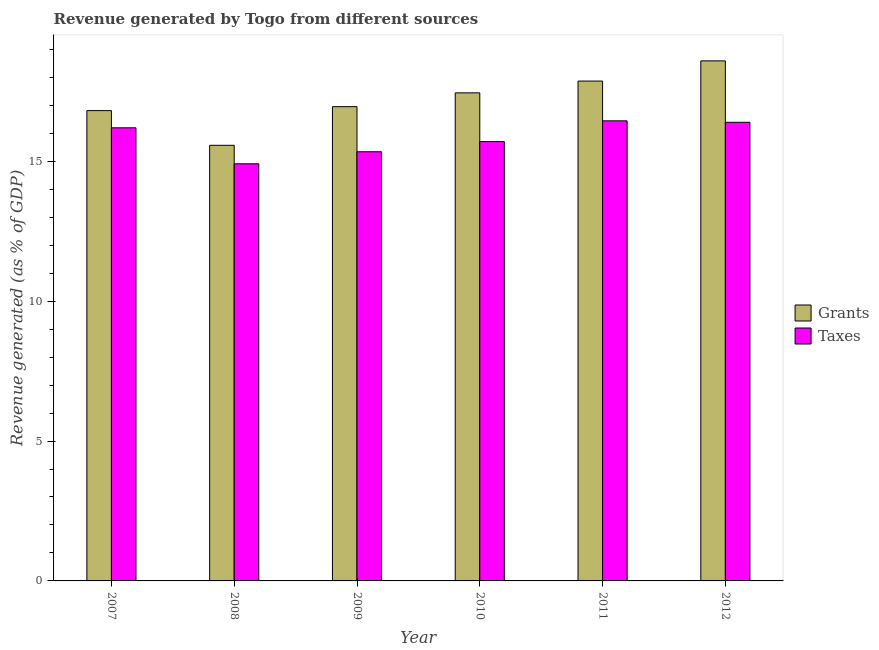How many different coloured bars are there?
Make the answer very short. 2. Are the number of bars per tick equal to the number of legend labels?
Your response must be concise. Yes. Are the number of bars on each tick of the X-axis equal?
Give a very brief answer. Yes. In how many cases, is the number of bars for a given year not equal to the number of legend labels?
Offer a very short reply. 0. What is the revenue generated by taxes in 2011?
Ensure brevity in your answer.  16.44. Across all years, what is the maximum revenue generated by taxes?
Offer a very short reply. 16.44. Across all years, what is the minimum revenue generated by grants?
Offer a very short reply. 15.57. In which year was the revenue generated by taxes maximum?
Your response must be concise. 2011. What is the total revenue generated by grants in the graph?
Make the answer very short. 103.22. What is the difference between the revenue generated by grants in 2007 and that in 2012?
Your response must be concise. -1.78. What is the difference between the revenue generated by grants in 2012 and the revenue generated by taxes in 2009?
Provide a succinct answer. 1.64. What is the average revenue generated by taxes per year?
Give a very brief answer. 15.83. In the year 2007, what is the difference between the revenue generated by grants and revenue generated by taxes?
Your answer should be compact. 0. In how many years, is the revenue generated by grants greater than 18 %?
Provide a succinct answer. 1. What is the ratio of the revenue generated by grants in 2007 to that in 2011?
Give a very brief answer. 0.94. What is the difference between the highest and the second highest revenue generated by grants?
Make the answer very short. 0.72. What is the difference between the highest and the lowest revenue generated by grants?
Your response must be concise. 3.02. In how many years, is the revenue generated by taxes greater than the average revenue generated by taxes taken over all years?
Your answer should be very brief. 3. What does the 1st bar from the left in 2011 represents?
Offer a terse response. Grants. What does the 2nd bar from the right in 2007 represents?
Your response must be concise. Grants. How many bars are there?
Your response must be concise. 12. Are all the bars in the graph horizontal?
Offer a very short reply. No. How many years are there in the graph?
Ensure brevity in your answer.  6. What is the difference between two consecutive major ticks on the Y-axis?
Your answer should be very brief. 5. Does the graph contain any zero values?
Ensure brevity in your answer.  No. Where does the legend appear in the graph?
Keep it short and to the point. Center right. What is the title of the graph?
Make the answer very short. Revenue generated by Togo from different sources. What is the label or title of the Y-axis?
Give a very brief answer. Revenue generated (as % of GDP). What is the Revenue generated (as % of GDP) in Grants in 2007?
Give a very brief answer. 16.81. What is the Revenue generated (as % of GDP) in Taxes in 2007?
Give a very brief answer. 16.2. What is the Revenue generated (as % of GDP) of Grants in 2008?
Ensure brevity in your answer.  15.57. What is the Revenue generated (as % of GDP) of Taxes in 2008?
Provide a succinct answer. 14.91. What is the Revenue generated (as % of GDP) in Grants in 2009?
Offer a terse response. 16.95. What is the Revenue generated (as % of GDP) of Taxes in 2009?
Give a very brief answer. 15.34. What is the Revenue generated (as % of GDP) of Grants in 2010?
Offer a terse response. 17.44. What is the Revenue generated (as % of GDP) in Taxes in 2010?
Provide a succinct answer. 15.7. What is the Revenue generated (as % of GDP) of Grants in 2011?
Provide a succinct answer. 17.87. What is the Revenue generated (as % of GDP) in Taxes in 2011?
Your response must be concise. 16.44. What is the Revenue generated (as % of GDP) in Grants in 2012?
Your answer should be compact. 18.59. What is the Revenue generated (as % of GDP) of Taxes in 2012?
Provide a succinct answer. 16.39. Across all years, what is the maximum Revenue generated (as % of GDP) of Grants?
Your response must be concise. 18.59. Across all years, what is the maximum Revenue generated (as % of GDP) in Taxes?
Your answer should be very brief. 16.44. Across all years, what is the minimum Revenue generated (as % of GDP) in Grants?
Your answer should be compact. 15.57. Across all years, what is the minimum Revenue generated (as % of GDP) of Taxes?
Make the answer very short. 14.91. What is the total Revenue generated (as % of GDP) in Grants in the graph?
Ensure brevity in your answer.  103.22. What is the total Revenue generated (as % of GDP) of Taxes in the graph?
Provide a short and direct response. 94.98. What is the difference between the Revenue generated (as % of GDP) in Grants in 2007 and that in 2008?
Keep it short and to the point. 1.24. What is the difference between the Revenue generated (as % of GDP) in Taxes in 2007 and that in 2008?
Keep it short and to the point. 1.29. What is the difference between the Revenue generated (as % of GDP) in Grants in 2007 and that in 2009?
Offer a terse response. -0.14. What is the difference between the Revenue generated (as % of GDP) of Taxes in 2007 and that in 2009?
Ensure brevity in your answer.  0.86. What is the difference between the Revenue generated (as % of GDP) of Grants in 2007 and that in 2010?
Provide a succinct answer. -0.64. What is the difference between the Revenue generated (as % of GDP) of Taxes in 2007 and that in 2010?
Offer a very short reply. 0.49. What is the difference between the Revenue generated (as % of GDP) of Grants in 2007 and that in 2011?
Make the answer very short. -1.06. What is the difference between the Revenue generated (as % of GDP) of Taxes in 2007 and that in 2011?
Keep it short and to the point. -0.25. What is the difference between the Revenue generated (as % of GDP) of Grants in 2007 and that in 2012?
Offer a very short reply. -1.78. What is the difference between the Revenue generated (as % of GDP) of Taxes in 2007 and that in 2012?
Provide a succinct answer. -0.2. What is the difference between the Revenue generated (as % of GDP) of Grants in 2008 and that in 2009?
Keep it short and to the point. -1.38. What is the difference between the Revenue generated (as % of GDP) in Taxes in 2008 and that in 2009?
Your response must be concise. -0.43. What is the difference between the Revenue generated (as % of GDP) of Grants in 2008 and that in 2010?
Your answer should be very brief. -1.87. What is the difference between the Revenue generated (as % of GDP) in Taxes in 2008 and that in 2010?
Your answer should be very brief. -0.79. What is the difference between the Revenue generated (as % of GDP) of Grants in 2008 and that in 2011?
Give a very brief answer. -2.3. What is the difference between the Revenue generated (as % of GDP) of Taxes in 2008 and that in 2011?
Offer a terse response. -1.53. What is the difference between the Revenue generated (as % of GDP) of Grants in 2008 and that in 2012?
Your answer should be very brief. -3.02. What is the difference between the Revenue generated (as % of GDP) in Taxes in 2008 and that in 2012?
Keep it short and to the point. -1.48. What is the difference between the Revenue generated (as % of GDP) of Grants in 2009 and that in 2010?
Make the answer very short. -0.49. What is the difference between the Revenue generated (as % of GDP) of Taxes in 2009 and that in 2010?
Your answer should be compact. -0.36. What is the difference between the Revenue generated (as % of GDP) in Grants in 2009 and that in 2011?
Your answer should be very brief. -0.91. What is the difference between the Revenue generated (as % of GDP) of Taxes in 2009 and that in 2011?
Make the answer very short. -1.1. What is the difference between the Revenue generated (as % of GDP) in Grants in 2009 and that in 2012?
Provide a short and direct response. -1.64. What is the difference between the Revenue generated (as % of GDP) in Taxes in 2009 and that in 2012?
Offer a terse response. -1.05. What is the difference between the Revenue generated (as % of GDP) in Grants in 2010 and that in 2011?
Ensure brevity in your answer.  -0.42. What is the difference between the Revenue generated (as % of GDP) in Taxes in 2010 and that in 2011?
Keep it short and to the point. -0.74. What is the difference between the Revenue generated (as % of GDP) of Grants in 2010 and that in 2012?
Ensure brevity in your answer.  -1.14. What is the difference between the Revenue generated (as % of GDP) in Taxes in 2010 and that in 2012?
Offer a very short reply. -0.69. What is the difference between the Revenue generated (as % of GDP) in Grants in 2011 and that in 2012?
Offer a terse response. -0.72. What is the difference between the Revenue generated (as % of GDP) of Taxes in 2011 and that in 2012?
Make the answer very short. 0.05. What is the difference between the Revenue generated (as % of GDP) in Grants in 2007 and the Revenue generated (as % of GDP) in Taxes in 2009?
Your answer should be very brief. 1.47. What is the difference between the Revenue generated (as % of GDP) in Grants in 2007 and the Revenue generated (as % of GDP) in Taxes in 2010?
Provide a short and direct response. 1.11. What is the difference between the Revenue generated (as % of GDP) of Grants in 2007 and the Revenue generated (as % of GDP) of Taxes in 2011?
Your answer should be very brief. 0.37. What is the difference between the Revenue generated (as % of GDP) in Grants in 2007 and the Revenue generated (as % of GDP) in Taxes in 2012?
Provide a short and direct response. 0.42. What is the difference between the Revenue generated (as % of GDP) in Grants in 2008 and the Revenue generated (as % of GDP) in Taxes in 2009?
Make the answer very short. 0.23. What is the difference between the Revenue generated (as % of GDP) of Grants in 2008 and the Revenue generated (as % of GDP) of Taxes in 2010?
Your response must be concise. -0.13. What is the difference between the Revenue generated (as % of GDP) in Grants in 2008 and the Revenue generated (as % of GDP) in Taxes in 2011?
Give a very brief answer. -0.87. What is the difference between the Revenue generated (as % of GDP) in Grants in 2008 and the Revenue generated (as % of GDP) in Taxes in 2012?
Keep it short and to the point. -0.82. What is the difference between the Revenue generated (as % of GDP) in Grants in 2009 and the Revenue generated (as % of GDP) in Taxes in 2010?
Provide a short and direct response. 1.25. What is the difference between the Revenue generated (as % of GDP) in Grants in 2009 and the Revenue generated (as % of GDP) in Taxes in 2011?
Provide a succinct answer. 0.51. What is the difference between the Revenue generated (as % of GDP) of Grants in 2009 and the Revenue generated (as % of GDP) of Taxes in 2012?
Your response must be concise. 0.56. What is the difference between the Revenue generated (as % of GDP) of Grants in 2010 and the Revenue generated (as % of GDP) of Taxes in 2012?
Offer a very short reply. 1.05. What is the difference between the Revenue generated (as % of GDP) in Grants in 2011 and the Revenue generated (as % of GDP) in Taxes in 2012?
Your response must be concise. 1.47. What is the average Revenue generated (as % of GDP) in Grants per year?
Keep it short and to the point. 17.2. What is the average Revenue generated (as % of GDP) in Taxes per year?
Make the answer very short. 15.83. In the year 2007, what is the difference between the Revenue generated (as % of GDP) of Grants and Revenue generated (as % of GDP) of Taxes?
Give a very brief answer. 0.61. In the year 2008, what is the difference between the Revenue generated (as % of GDP) of Grants and Revenue generated (as % of GDP) of Taxes?
Offer a very short reply. 0.66. In the year 2009, what is the difference between the Revenue generated (as % of GDP) of Grants and Revenue generated (as % of GDP) of Taxes?
Your response must be concise. 1.61. In the year 2010, what is the difference between the Revenue generated (as % of GDP) in Grants and Revenue generated (as % of GDP) in Taxes?
Your answer should be compact. 1.74. In the year 2011, what is the difference between the Revenue generated (as % of GDP) of Grants and Revenue generated (as % of GDP) of Taxes?
Keep it short and to the point. 1.42. In the year 2012, what is the difference between the Revenue generated (as % of GDP) in Grants and Revenue generated (as % of GDP) in Taxes?
Give a very brief answer. 2.19. What is the ratio of the Revenue generated (as % of GDP) in Grants in 2007 to that in 2008?
Ensure brevity in your answer.  1.08. What is the ratio of the Revenue generated (as % of GDP) of Taxes in 2007 to that in 2008?
Offer a terse response. 1.09. What is the ratio of the Revenue generated (as % of GDP) in Grants in 2007 to that in 2009?
Keep it short and to the point. 0.99. What is the ratio of the Revenue generated (as % of GDP) of Taxes in 2007 to that in 2009?
Provide a short and direct response. 1.06. What is the ratio of the Revenue generated (as % of GDP) of Grants in 2007 to that in 2010?
Your response must be concise. 0.96. What is the ratio of the Revenue generated (as % of GDP) in Taxes in 2007 to that in 2010?
Offer a very short reply. 1.03. What is the ratio of the Revenue generated (as % of GDP) of Grants in 2007 to that in 2011?
Your answer should be very brief. 0.94. What is the ratio of the Revenue generated (as % of GDP) of Taxes in 2007 to that in 2011?
Your answer should be compact. 0.98. What is the ratio of the Revenue generated (as % of GDP) of Grants in 2007 to that in 2012?
Your answer should be compact. 0.9. What is the ratio of the Revenue generated (as % of GDP) of Taxes in 2007 to that in 2012?
Your answer should be very brief. 0.99. What is the ratio of the Revenue generated (as % of GDP) of Grants in 2008 to that in 2009?
Keep it short and to the point. 0.92. What is the ratio of the Revenue generated (as % of GDP) in Grants in 2008 to that in 2010?
Keep it short and to the point. 0.89. What is the ratio of the Revenue generated (as % of GDP) of Taxes in 2008 to that in 2010?
Your answer should be very brief. 0.95. What is the ratio of the Revenue generated (as % of GDP) in Grants in 2008 to that in 2011?
Provide a succinct answer. 0.87. What is the ratio of the Revenue generated (as % of GDP) in Taxes in 2008 to that in 2011?
Keep it short and to the point. 0.91. What is the ratio of the Revenue generated (as % of GDP) in Grants in 2008 to that in 2012?
Your answer should be very brief. 0.84. What is the ratio of the Revenue generated (as % of GDP) of Taxes in 2008 to that in 2012?
Provide a short and direct response. 0.91. What is the ratio of the Revenue generated (as % of GDP) of Grants in 2009 to that in 2010?
Offer a terse response. 0.97. What is the ratio of the Revenue generated (as % of GDP) of Taxes in 2009 to that in 2010?
Keep it short and to the point. 0.98. What is the ratio of the Revenue generated (as % of GDP) in Grants in 2009 to that in 2011?
Give a very brief answer. 0.95. What is the ratio of the Revenue generated (as % of GDP) of Taxes in 2009 to that in 2011?
Make the answer very short. 0.93. What is the ratio of the Revenue generated (as % of GDP) in Grants in 2009 to that in 2012?
Keep it short and to the point. 0.91. What is the ratio of the Revenue generated (as % of GDP) in Taxes in 2009 to that in 2012?
Ensure brevity in your answer.  0.94. What is the ratio of the Revenue generated (as % of GDP) of Grants in 2010 to that in 2011?
Your response must be concise. 0.98. What is the ratio of the Revenue generated (as % of GDP) of Taxes in 2010 to that in 2011?
Your answer should be compact. 0.95. What is the ratio of the Revenue generated (as % of GDP) in Grants in 2010 to that in 2012?
Ensure brevity in your answer.  0.94. What is the ratio of the Revenue generated (as % of GDP) in Taxes in 2010 to that in 2012?
Offer a very short reply. 0.96. What is the ratio of the Revenue generated (as % of GDP) of Grants in 2011 to that in 2012?
Ensure brevity in your answer.  0.96. What is the difference between the highest and the second highest Revenue generated (as % of GDP) in Grants?
Make the answer very short. 0.72. What is the difference between the highest and the second highest Revenue generated (as % of GDP) of Taxes?
Make the answer very short. 0.05. What is the difference between the highest and the lowest Revenue generated (as % of GDP) of Grants?
Give a very brief answer. 3.02. What is the difference between the highest and the lowest Revenue generated (as % of GDP) of Taxes?
Offer a very short reply. 1.53. 